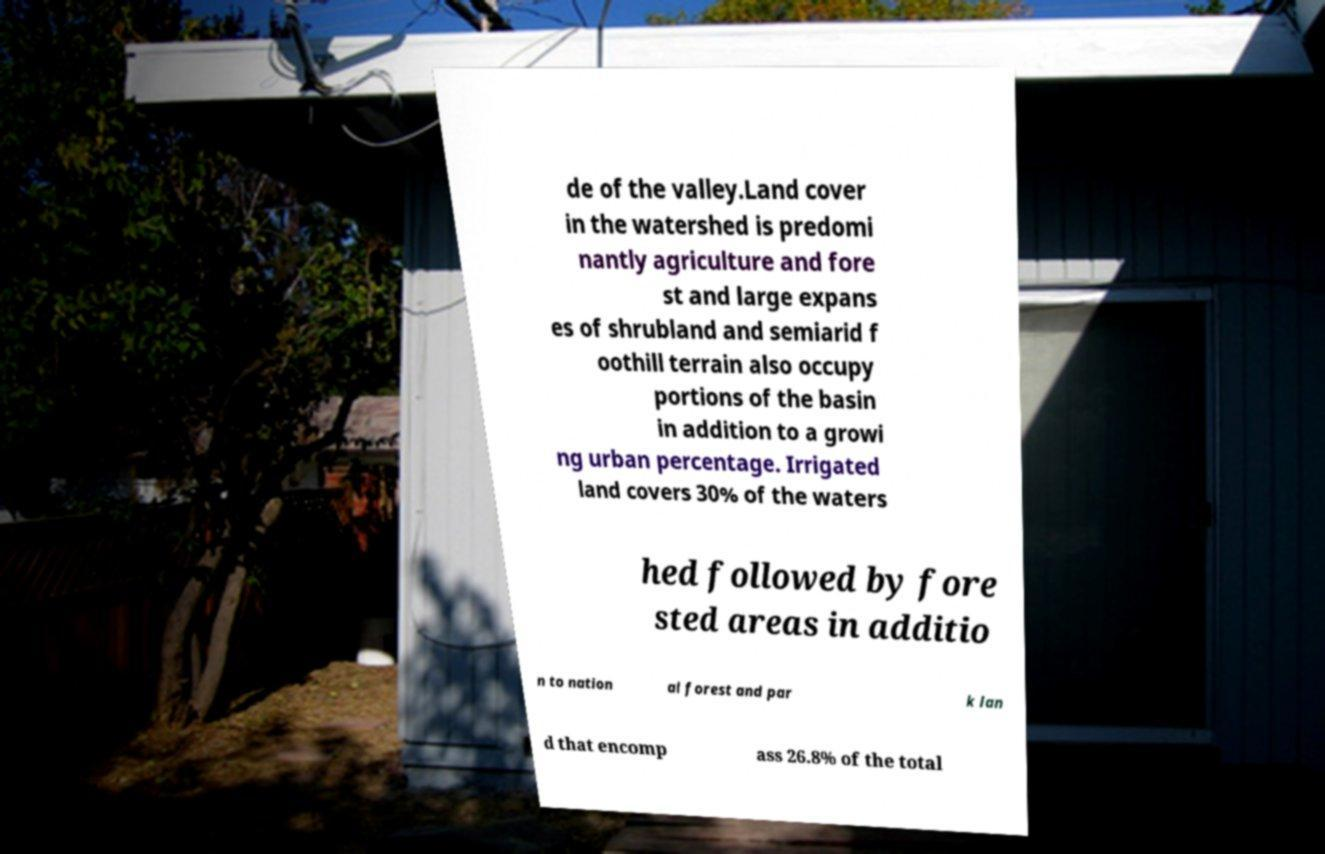Could you assist in decoding the text presented in this image and type it out clearly? de of the valley.Land cover in the watershed is predomi nantly agriculture and fore st and large expans es of shrubland and semiarid f oothill terrain also occupy portions of the basin in addition to a growi ng urban percentage. Irrigated land covers 30% of the waters hed followed by fore sted areas in additio n to nation al forest and par k lan d that encomp ass 26.8% of the total 